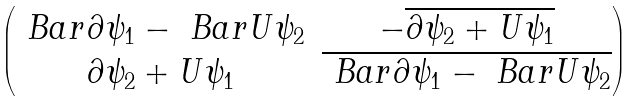Convert formula to latex. <formula><loc_0><loc_0><loc_500><loc_500>\begin{pmatrix} \ B a r { \partial } \psi _ { 1 } - \ B a r { U } \psi _ { 2 } & - \overline { \partial \psi _ { 2 } + U \psi _ { 1 } } \\ \partial \psi _ { 2 } + U \psi _ { 1 } & \overline { \ B a r { \partial } \psi _ { 1 } - \ B a r { U } \psi _ { 2 } } \end{pmatrix}</formula> 